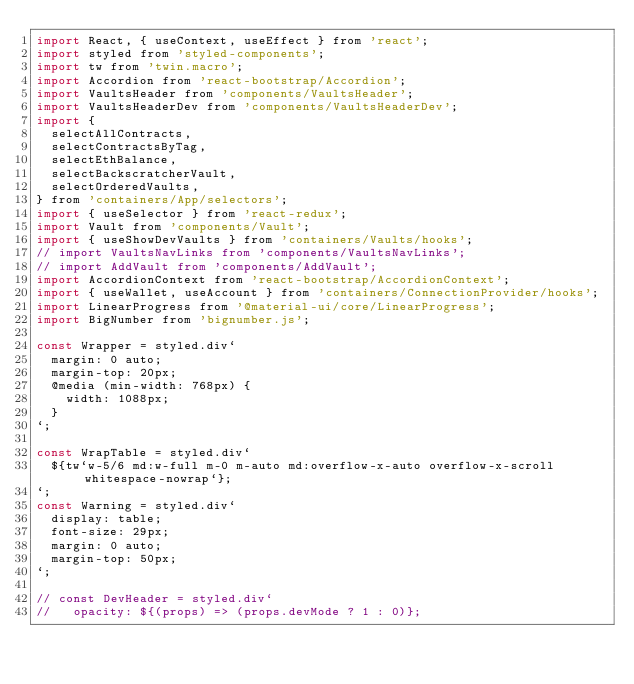<code> <loc_0><loc_0><loc_500><loc_500><_JavaScript_>import React, { useContext, useEffect } from 'react';
import styled from 'styled-components';
import tw from 'twin.macro';
import Accordion from 'react-bootstrap/Accordion';
import VaultsHeader from 'components/VaultsHeader';
import VaultsHeaderDev from 'components/VaultsHeaderDev';
import {
  selectAllContracts,
  selectContractsByTag,
  selectEthBalance,
  selectBackscratcherVault,
  selectOrderedVaults,
} from 'containers/App/selectors';
import { useSelector } from 'react-redux';
import Vault from 'components/Vault';
import { useShowDevVaults } from 'containers/Vaults/hooks';
// import VaultsNavLinks from 'components/VaultsNavLinks';
// import AddVault from 'components/AddVault';
import AccordionContext from 'react-bootstrap/AccordionContext';
import { useWallet, useAccount } from 'containers/ConnectionProvider/hooks';
import LinearProgress from '@material-ui/core/LinearProgress';
import BigNumber from 'bignumber.js';

const Wrapper = styled.div`
  margin: 0 auto;
  margin-top: 20px;
  @media (min-width: 768px) {
    width: 1088px;
  }
`;

const WrapTable = styled.div`
  ${tw`w-5/6 md:w-full m-0 m-auto md:overflow-x-auto overflow-x-scroll whitespace-nowrap`};
`;
const Warning = styled.div`
  display: table;
  font-size: 29px;
  margin: 0 auto;
  margin-top: 50px;
`;

// const DevHeader = styled.div`
//   opacity: ${(props) => (props.devMode ? 1 : 0)};</code> 